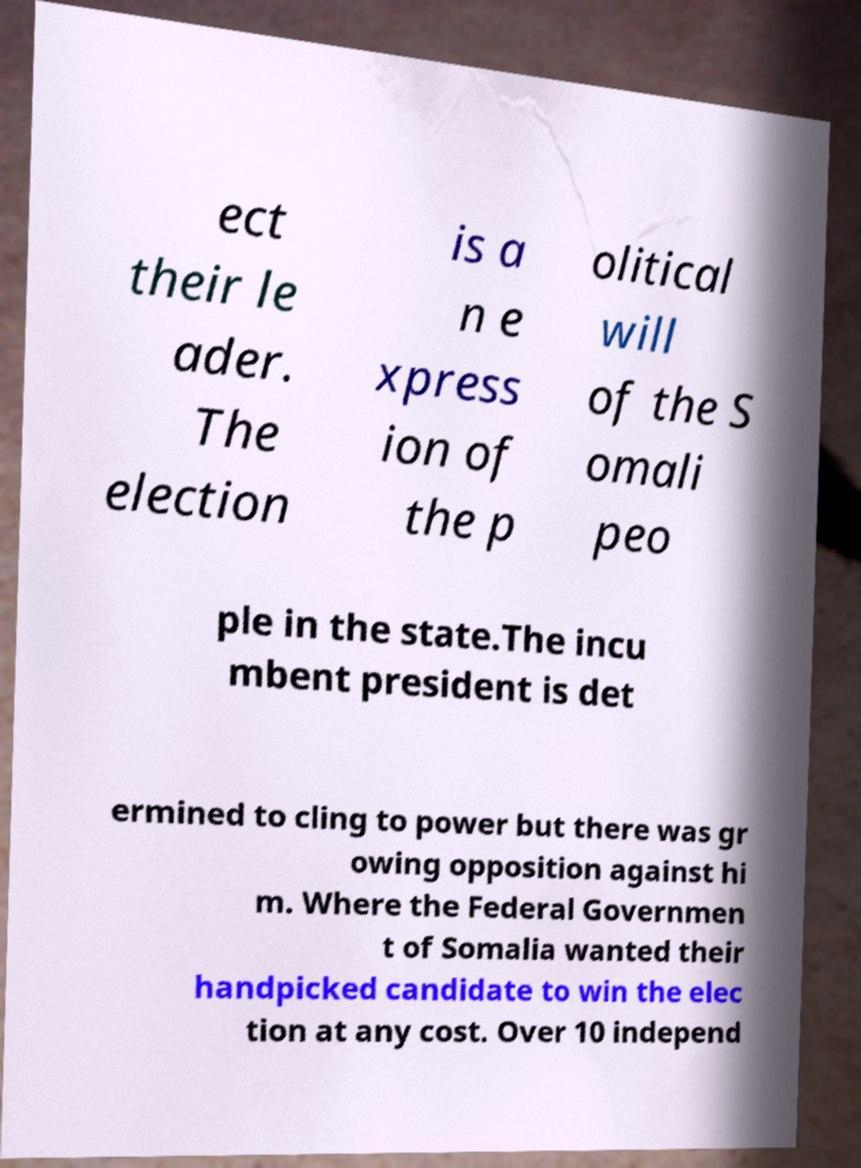Can you accurately transcribe the text from the provided image for me? ect their le ader. The election is a n e xpress ion of the p olitical will of the S omali peo ple in the state.The incu mbent president is det ermined to cling to power but there was gr owing opposition against hi m. Where the Federal Governmen t of Somalia wanted their handpicked candidate to win the elec tion at any cost. Over 10 independ 